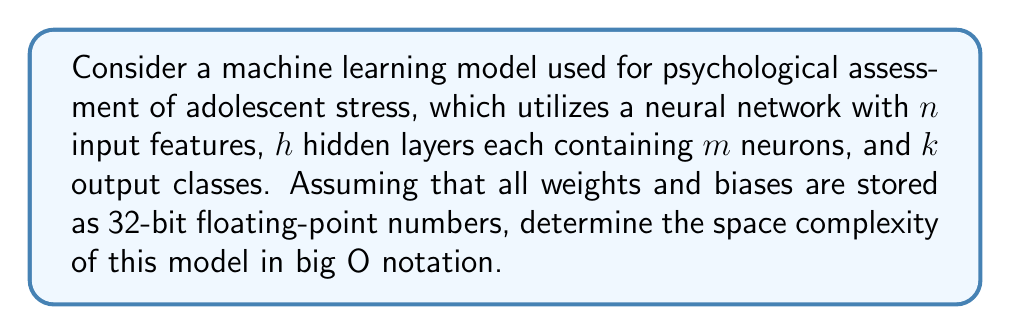Give your solution to this math problem. To determine the space complexity, we need to calculate the total number of parameters (weights and biases) in the neural network:

1. Input layer to first hidden layer:
   - Number of weights: $n \times m$
   - Number of biases: $m$

2. Between hidden layers:
   - Number of weights per layer: $m \times m$
   - Number of biases per layer: $m$
   - Total for $(h-1)$ connections between hidden layers:
     $(h-1) \times (m \times m + m)$

3. Last hidden layer to output layer:
   - Number of weights: $m \times k$
   - Number of biases: $k$

Total number of parameters:
$$(n \times m + m) + (h-1) \times (m \times m + m) + (m \times k + k)$$

Simplifying:
$$nm + m + (h-1)(m^2 + m) + mk + k$$
$$= nm + hm^2 + hm - m^2 - m + mk + k$$
$$= O(nm + hm^2 + mk)$$

Since each parameter is stored as a 32-bit (4-byte) floating-point number, the total space required is:

$$O(4(nm + hm^2 + mk))$$

The constant factor 4 can be dropped in big O notation, resulting in:

$$O(nm + hm^2 + mk)$$

This represents the space complexity of the neural network model.
Answer: $O(nm + hm^2 + mk)$ 